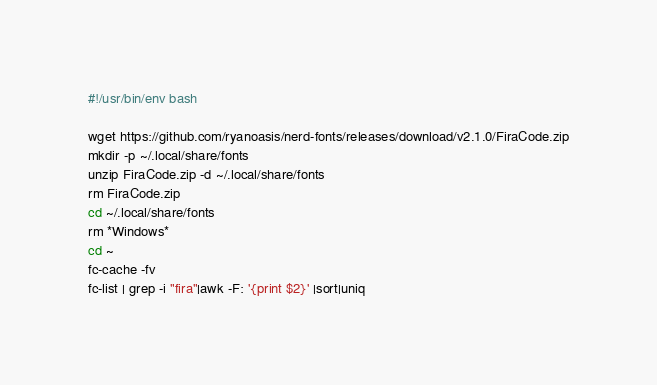<code> <loc_0><loc_0><loc_500><loc_500><_Bash_>#!/usr/bin/env bash

wget https://github.com/ryanoasis/nerd-fonts/releases/download/v2.1.0/FiraCode.zip
mkdir -p ~/.local/share/fonts
unzip FiraCode.zip -d ~/.local/share/fonts
rm FiraCode.zip
cd ~/.local/share/fonts
rm *Windows*
cd ~
fc-cache -fv
fc-list | grep -i "fira"|awk -F: '{print $2}' |sort|uniq
</code> 